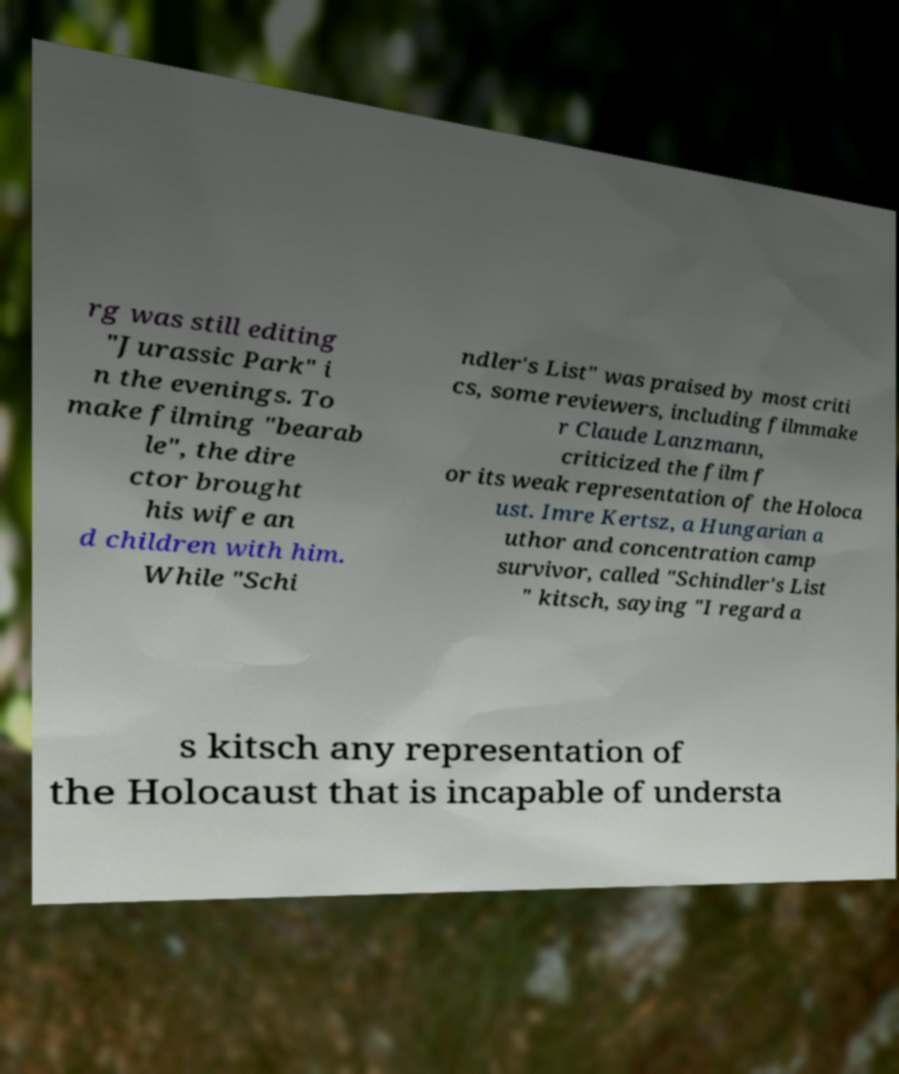Can you accurately transcribe the text from the provided image for me? rg was still editing "Jurassic Park" i n the evenings. To make filming "bearab le", the dire ctor brought his wife an d children with him. While "Schi ndler's List" was praised by most criti cs, some reviewers, including filmmake r Claude Lanzmann, criticized the film f or its weak representation of the Holoca ust. Imre Kertsz, a Hungarian a uthor and concentration camp survivor, called "Schindler's List " kitsch, saying "I regard a s kitsch any representation of the Holocaust that is incapable of understa 